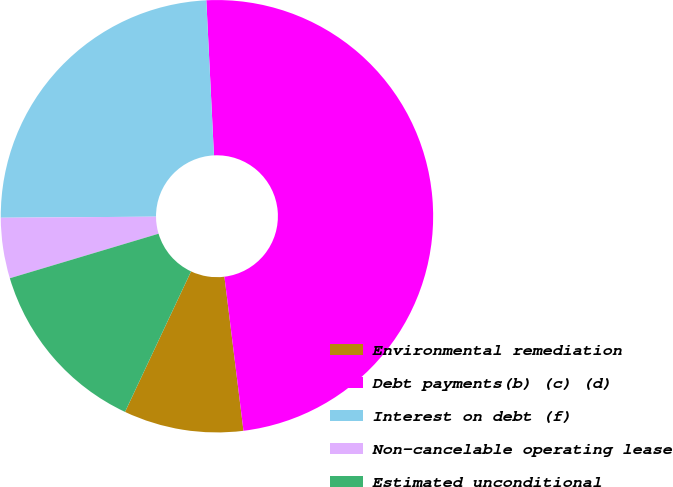<chart> <loc_0><loc_0><loc_500><loc_500><pie_chart><fcel>Environmental remediation<fcel>Debt payments(b) (c) (d)<fcel>Interest on debt (f)<fcel>Non-cancelable operating lease<fcel>Estimated unconditional<nl><fcel>8.95%<fcel>48.83%<fcel>24.33%<fcel>4.52%<fcel>13.38%<nl></chart> 